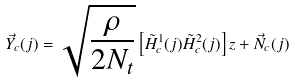<formula> <loc_0><loc_0><loc_500><loc_500>\vec { Y } _ { c } ( j ) = \sqrt { \frac { \rho } { 2 N _ { t } } } \left [ \tilde { H } ^ { 1 } _ { c } ( j ) \tilde { H } ^ { 2 } _ { c } ( j ) \right ] z + \vec { N } _ { c } ( j )</formula> 